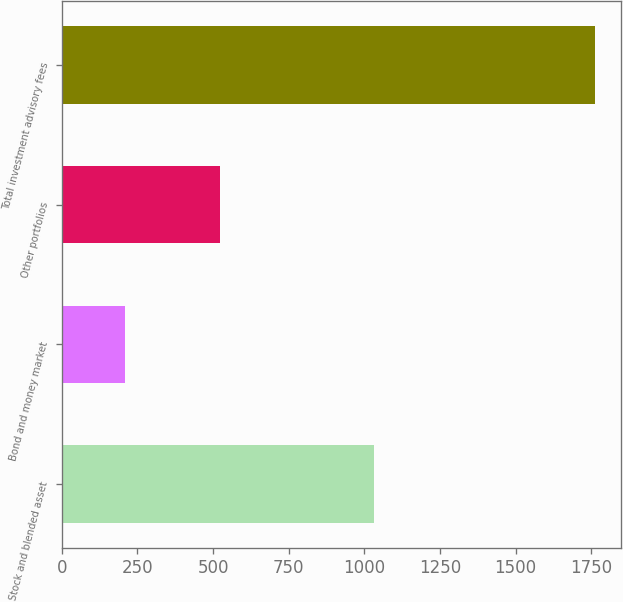<chart> <loc_0><loc_0><loc_500><loc_500><bar_chart><fcel>Stock and blended asset<fcel>Bond and money market<fcel>Other portfolios<fcel>Total investment advisory fees<nl><fcel>1031.4<fcel>207.4<fcel>522.2<fcel>1761<nl></chart> 